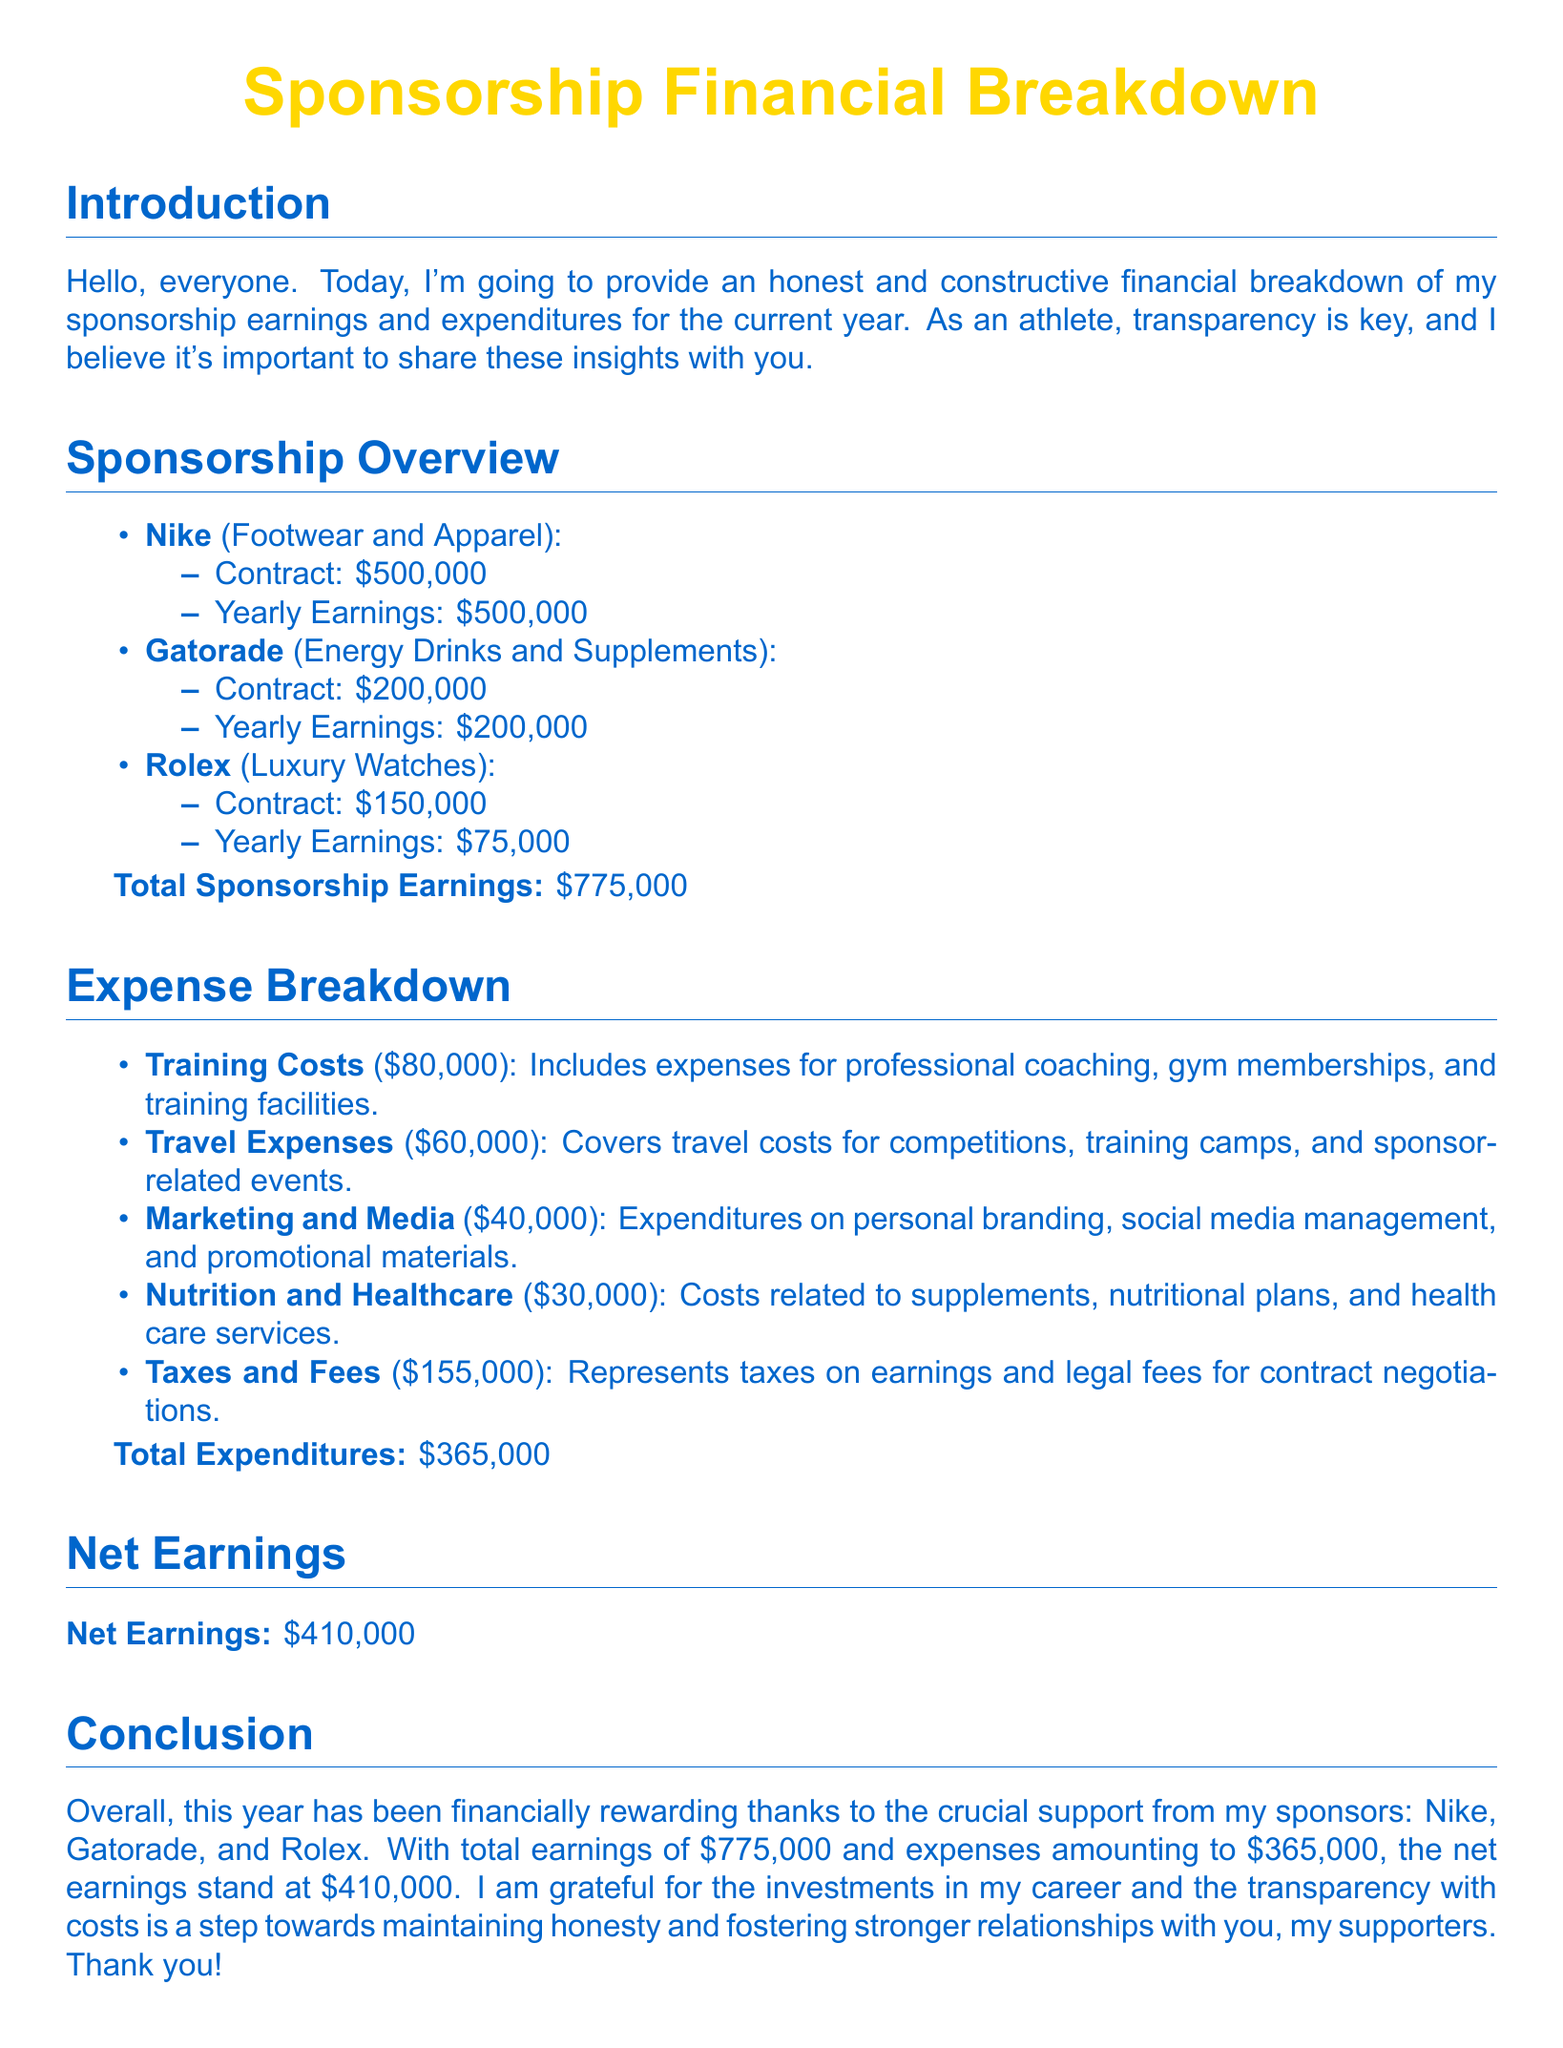What is the total sponsorship earnings? The total sponsorship earnings is the sum of all earnings from sponsors listed in the document.
Answer: $775,000 What is the contract amount with Nike? The contract amount with Nike is specified in the sponsorship overview section of the document.
Answer: $500,000 How much was spent on travel expenses? Travel expenses are outlined in the expense breakdown section of the document.
Answer: $60,000 What are the total expenditures? Total expenditures are calculated by summing all expenses listed in the document.
Answer: $365,000 What is the net earnings for the year? Net earnings are calculated by subtracting total expenditures from total sponsorship earnings in the document.
Answer: $410,000 Which sponsor provided the lowest yearly earnings? The sponsor with the lowest yearly earnings is indicated in the overview section of the document.
Answer: Rolex How much was spent on marketing and media? The expenditure on marketing and media is detailed in the expense breakdown.
Answer: $40,000 What is the main purpose of this document? The main purpose of this document is outlined in the introduction where it emphasizes transparency and financial breakdown.
Answer: Financial breakdown How much was allocated for nutrition and healthcare? The allocation for nutrition and healthcare is specified in the expense breakdown section.
Answer: $30,000 Which sponsorship results in the highest earnings? The highest earnings from sponsorship are noted in the sponsorship overview section of the document.
Answer: Nike 